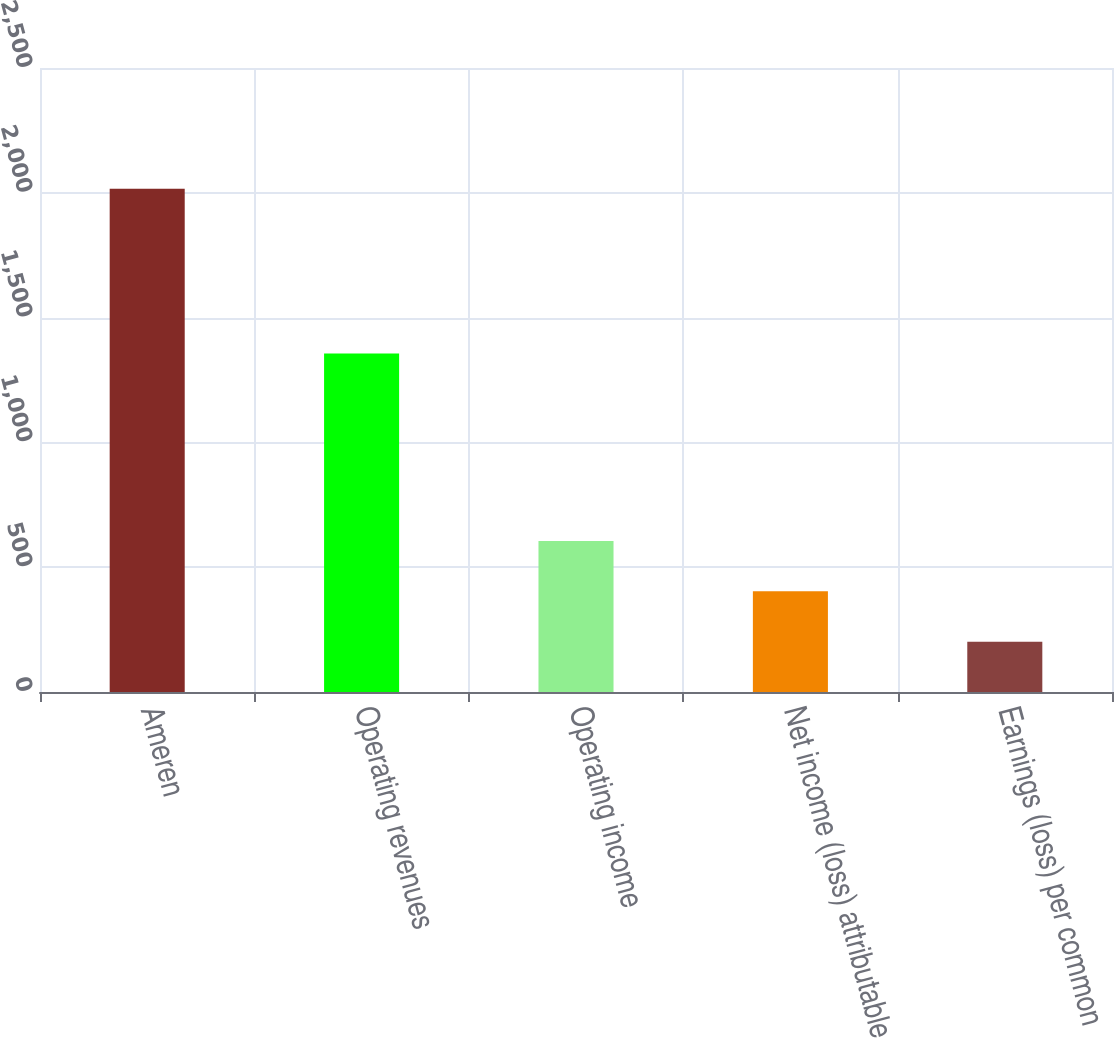<chart> <loc_0><loc_0><loc_500><loc_500><bar_chart><fcel>Ameren<fcel>Operating revenues<fcel>Operating income<fcel>Net income (loss) attributable<fcel>Earnings (loss) per common<nl><fcel>2016<fcel>1356<fcel>604.9<fcel>403.31<fcel>201.72<nl></chart> 